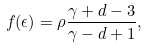<formula> <loc_0><loc_0><loc_500><loc_500>f ( \epsilon ) = \rho { \frac { \gamma + d - 3 } { \gamma - d + 1 } } ,</formula> 